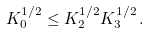Convert formula to latex. <formula><loc_0><loc_0><loc_500><loc_500>K _ { 0 } ^ { 1 / 2 } \leq K _ { 2 } ^ { 1 / 2 } K _ { 3 } ^ { 1 / 2 } \, .</formula> 